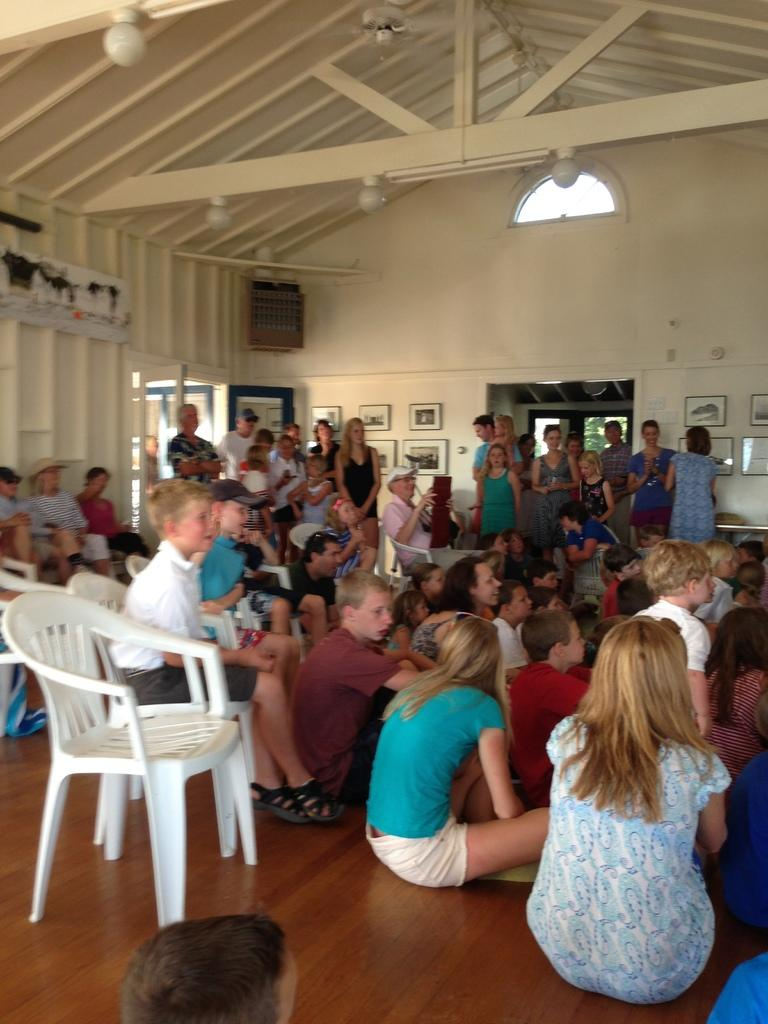What positions are the people in the image taking? There are people sitting on the floor and chairs, as well as people standing in the image. Can you describe the arrangement of the people in the image? The people are either sitting or standing, with some on the floor and others on chairs. What type of doctor is attending to the people in the image? There is no doctor present in the image; it only shows people sitting, standing, or sitting on chairs. 